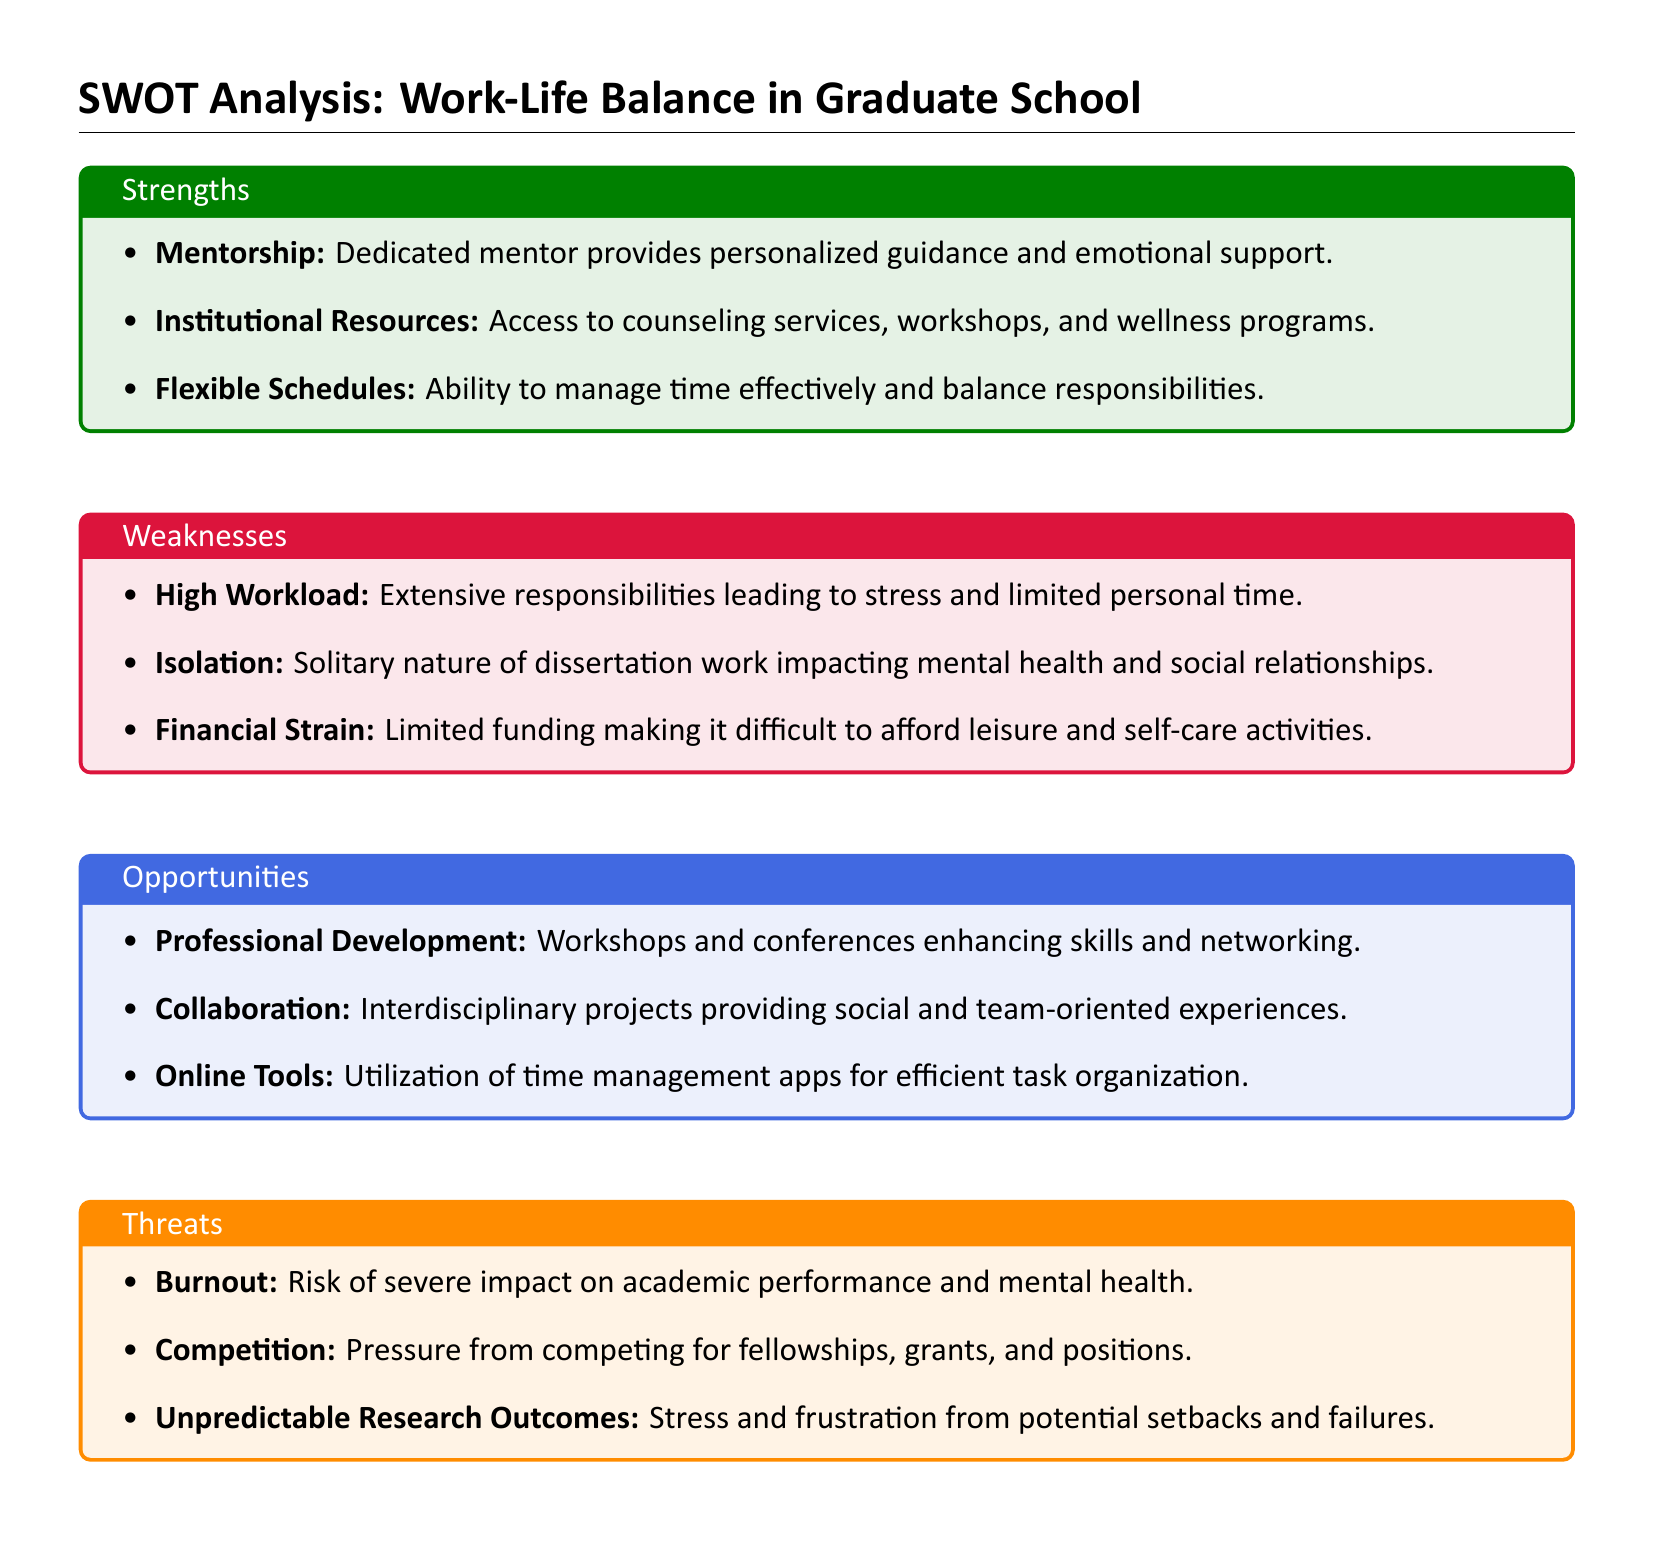What are two strengths mentioned in the SWOT analysis? The strengths include personalized guidance and emotional support and access to counseling services and wellness programs.
Answer: Mentorship, Institutional Resources What is one identified weakness related to workload? The document states that extensive responsibilities lead to stress and limited personal time.
Answer: High Workload What opportunity relates to skill enhancement? The SWOT analysis mentions workshops and conferences that enhance skills.
Answer: Professional Development What threat is associated with mental health? The document indicates that burnout has a severe impact on academic performance and mental health.
Answer: Burnout How many areas are covered in the SWOT analysis? The structure of the document includes four areas, which are strengths, weaknesses, opportunities, and threats.
Answer: Four What online tool is suggested for time management? The SWOT analysis recommends utilizing time management apps for efficient task organization.
Answer: Online Tools Which strength relates to scheduling? The analysis highlights the ability to manage time effectively as a strength.
Answer: Flexible Schedules What is a potential outcome of unpredictable research? The document explains that researchers may face stress and frustration from potential setbacks and failures.
Answer: Stress and frustration 